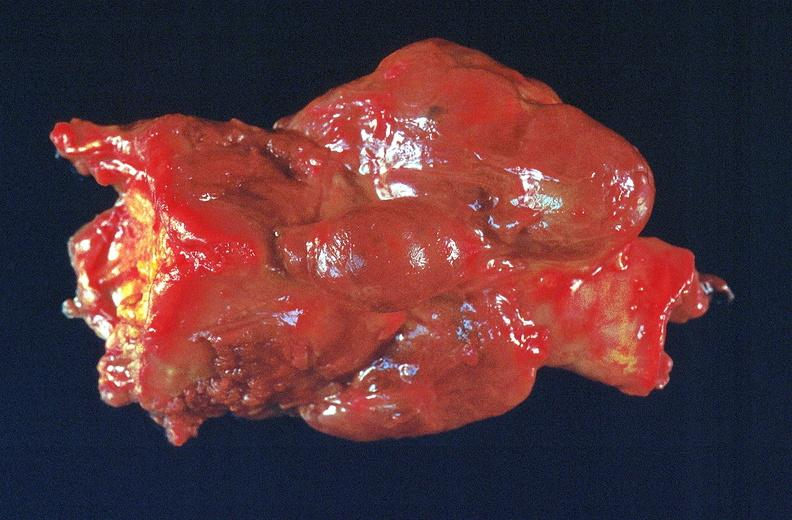what does this image show?
Answer the question using a single word or phrase. Thyroid 